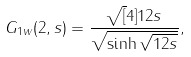<formula> <loc_0><loc_0><loc_500><loc_500>G _ { 1 w } ( 2 , s ) = \frac { \sqrt { [ } 4 ] { 1 2 s } } { \sqrt { \sinh \sqrt { 1 2 s } } } ,</formula> 